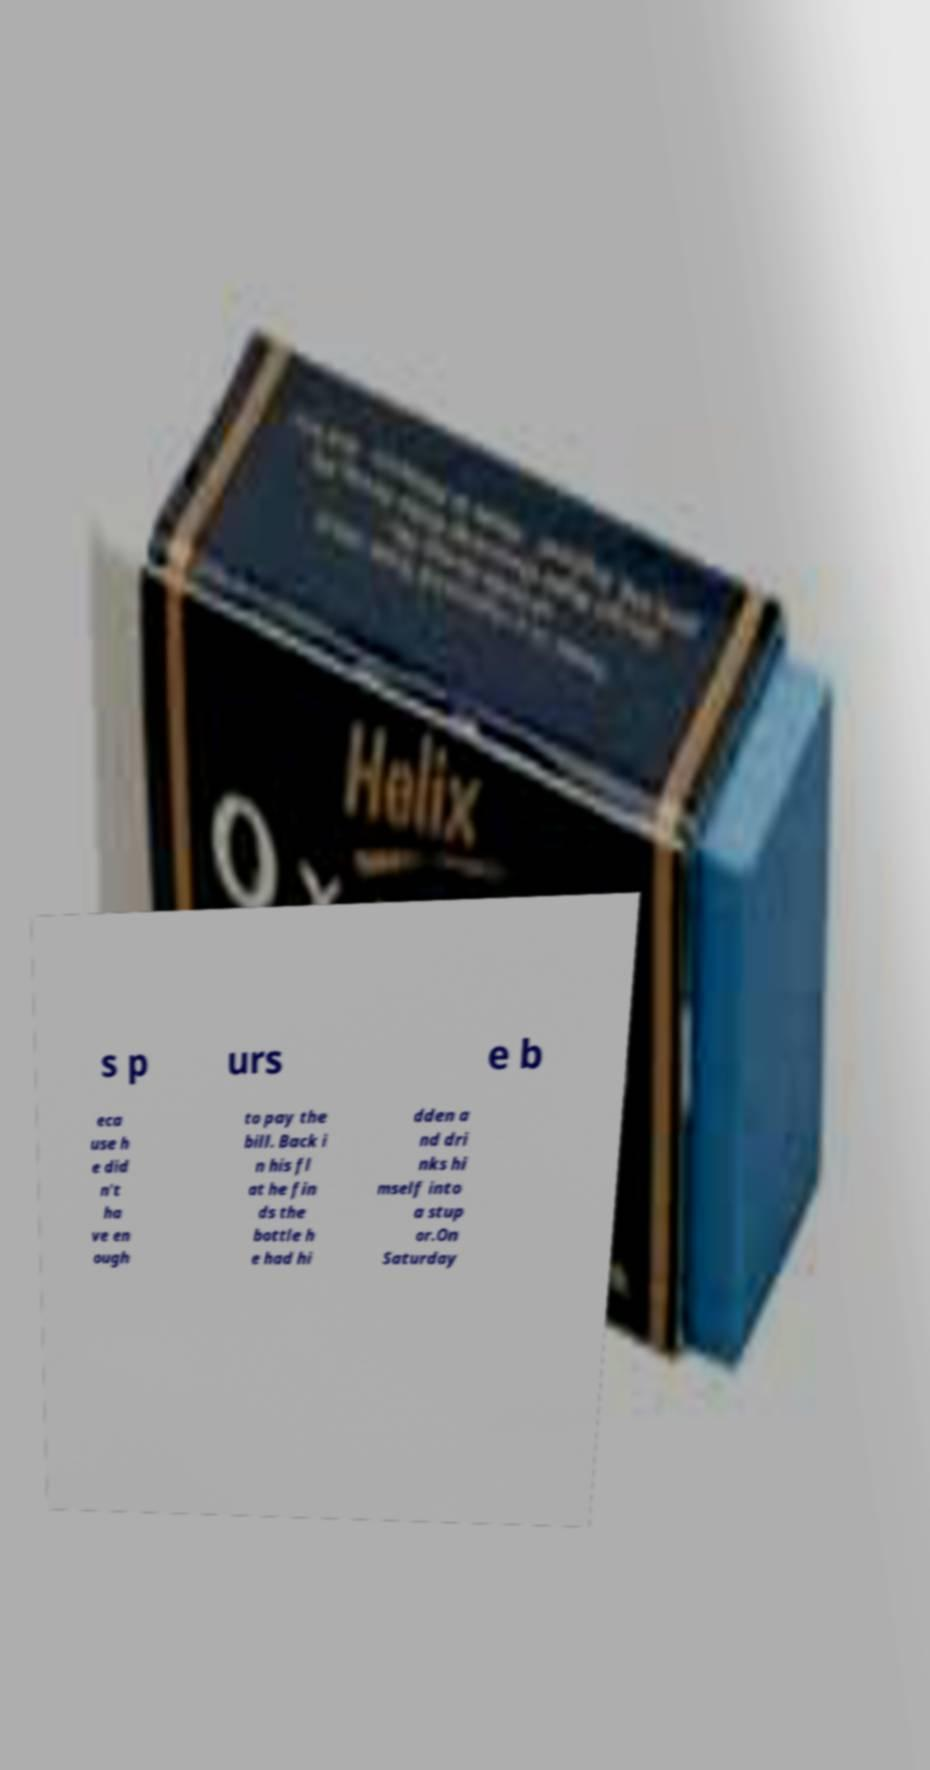There's text embedded in this image that I need extracted. Can you transcribe it verbatim? s p urs e b eca use h e did n't ha ve en ough to pay the bill. Back i n his fl at he fin ds the bottle h e had hi dden a nd dri nks hi mself into a stup or.On Saturday 